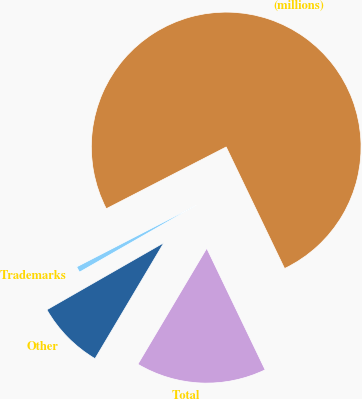Convert chart. <chart><loc_0><loc_0><loc_500><loc_500><pie_chart><fcel>(millions)<fcel>Trademarks<fcel>Other<fcel>Total<nl><fcel>75.44%<fcel>0.71%<fcel>8.19%<fcel>15.66%<nl></chart> 